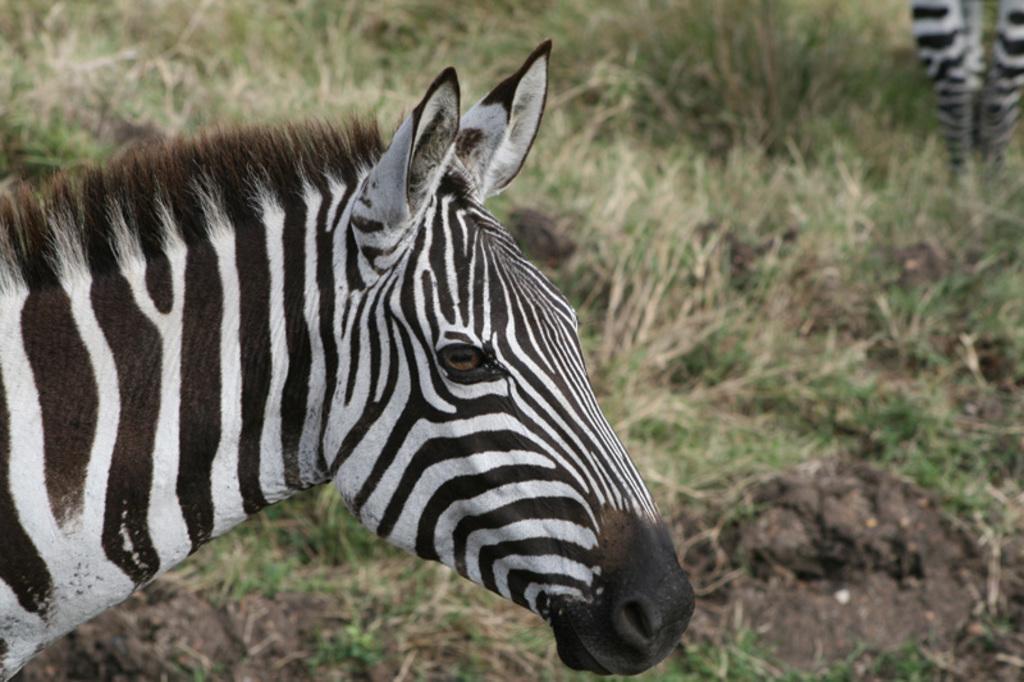How would you summarize this image in a sentence or two? In the image there is a zebra and only the head of the zebra is visible in the image,in the background there is a grass and another zebra is standing on the grass. 